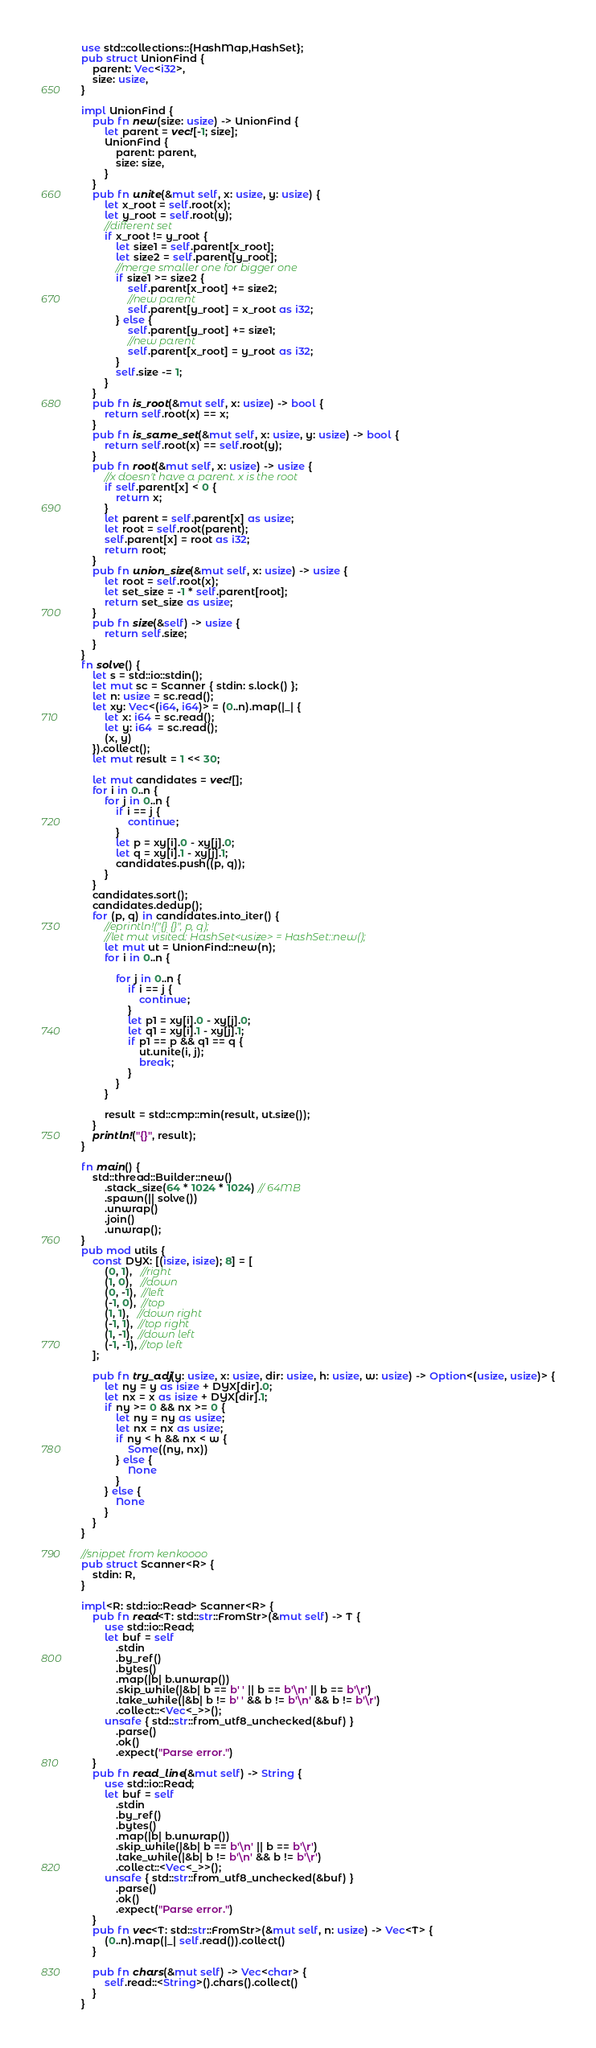<code> <loc_0><loc_0><loc_500><loc_500><_Rust_>use std::collections::{HashMap,HashSet};
pub struct UnionFind {
    parent: Vec<i32>,
    size: usize,
}

impl UnionFind {
    pub fn new(size: usize) -> UnionFind {
        let parent = vec![-1; size];
        UnionFind {
            parent: parent,
            size: size,
        }
    }
    pub fn unite(&mut self, x: usize, y: usize) {
        let x_root = self.root(x);
        let y_root = self.root(y);
        //different set
        if x_root != y_root {
            let size1 = self.parent[x_root];
            let size2 = self.parent[y_root];
            //merge smaller one for bigger one
            if size1 >= size2 {
                self.parent[x_root] += size2;
                //new parent
                self.parent[y_root] = x_root as i32;
            } else {
                self.parent[y_root] += size1;
                //new parent
                self.parent[x_root] = y_root as i32;
            }
            self.size -= 1;
        }
    }
    pub fn is_root(&mut self, x: usize) -> bool {
        return self.root(x) == x;
    }
    pub fn is_same_set(&mut self, x: usize, y: usize) -> bool {
        return self.root(x) == self.root(y);
    }
    pub fn root(&mut self, x: usize) -> usize {
        //x doesn't have a parent. x is the root
        if self.parent[x] < 0 {
            return x;
        }
        let parent = self.parent[x] as usize;
        let root = self.root(parent);
        self.parent[x] = root as i32;
        return root;
    }
    pub fn union_size(&mut self, x: usize) -> usize {
        let root = self.root(x);
        let set_size = -1 * self.parent[root];
        return set_size as usize;
    }
    pub fn size(&self) -> usize {
        return self.size;
    }
}
fn solve() {
    let s = std::io::stdin();
    let mut sc = Scanner { stdin: s.lock() };
    let n: usize = sc.read();
    let xy: Vec<(i64, i64)> = (0..n).map(|_| {
        let x: i64 = sc.read();
        let y: i64  = sc.read();
        (x, y)
    }).collect();
    let mut result = 1 << 30;
    
    let mut candidates = vec![];
    for i in 0..n {
        for j in 0..n {
            if i == j {
                continue;
            }
            let p = xy[i].0 - xy[j].0;
            let q = xy[i].1 - xy[j].1;
            candidates.push((p, q));
        }
    }
    candidates.sort();
    candidates.dedup();
    for (p, q) in candidates.into_iter() {
        //eprintln!("{} {}", p, q);
        //let mut visited: HashSet<usize> = HashSet::new();
        let mut ut = UnionFind::new(n);
        for i in 0..n {
            
            for j in 0..n {
                if i == j {
                    continue;
                }
                let p1 = xy[i].0 - xy[j].0;
                let q1 = xy[i].1 - xy[j].1;    
                if p1 == p && q1 == q {
                    ut.unite(i, j);
                    break;
                }
            }
        }
        
        result = std::cmp::min(result, ut.size());
    }
    println!("{}", result);
}

fn main() {
    std::thread::Builder::new()
        .stack_size(64 * 1024 * 1024) // 64MB
        .spawn(|| solve())
        .unwrap()
        .join()
        .unwrap();
}
pub mod utils {
    const DYX: [(isize, isize); 8] = [
        (0, 1),   //right
        (1, 0),   //down
        (0, -1),  //left
        (-1, 0),  //top
        (1, 1),   //down right
        (-1, 1),  //top right
        (1, -1),  //down left
        (-1, -1), //top left
    ];

    pub fn try_adj(y: usize, x: usize, dir: usize, h: usize, w: usize) -> Option<(usize, usize)> {
        let ny = y as isize + DYX[dir].0;
        let nx = x as isize + DYX[dir].1;
        if ny >= 0 && nx >= 0 {
            let ny = ny as usize;
            let nx = nx as usize;
            if ny < h && nx < w {
                Some((ny, nx))
            } else {
                None
            }
        } else {
            None
        }
    }
}

//snippet from kenkoooo
pub struct Scanner<R> {
    stdin: R,
}

impl<R: std::io::Read> Scanner<R> {
    pub fn read<T: std::str::FromStr>(&mut self) -> T {
        use std::io::Read;
        let buf = self
            .stdin
            .by_ref()
            .bytes()
            .map(|b| b.unwrap())
            .skip_while(|&b| b == b' ' || b == b'\n' || b == b'\r')
            .take_while(|&b| b != b' ' && b != b'\n' && b != b'\r')
            .collect::<Vec<_>>();
        unsafe { std::str::from_utf8_unchecked(&buf) }
            .parse()
            .ok()
            .expect("Parse error.")
    }
    pub fn read_line(&mut self) -> String {
        use std::io::Read;
        let buf = self
            .stdin
            .by_ref()
            .bytes()
            .map(|b| b.unwrap())
            .skip_while(|&b| b == b'\n' || b == b'\r')
            .take_while(|&b| b != b'\n' && b != b'\r')
            .collect::<Vec<_>>();
        unsafe { std::str::from_utf8_unchecked(&buf) }
            .parse()
            .ok()
            .expect("Parse error.")
    }
    pub fn vec<T: std::str::FromStr>(&mut self, n: usize) -> Vec<T> {
        (0..n).map(|_| self.read()).collect()
    }

    pub fn chars(&mut self) -> Vec<char> {
        self.read::<String>().chars().collect()
    }
}
</code> 